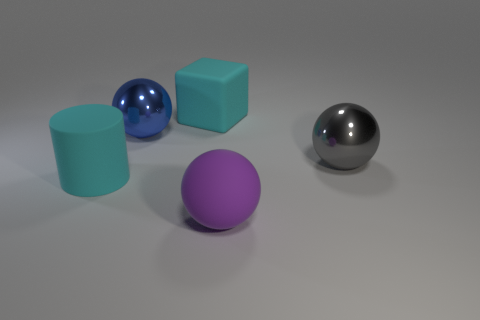Add 1 purple matte cylinders. How many objects exist? 6 Subtract all balls. How many objects are left? 2 Add 2 cyan things. How many cyan things are left? 4 Add 4 tiny red shiny blocks. How many tiny red shiny blocks exist? 4 Subtract 1 cyan blocks. How many objects are left? 4 Subtract all gray balls. Subtract all big cyan rubber cylinders. How many objects are left? 3 